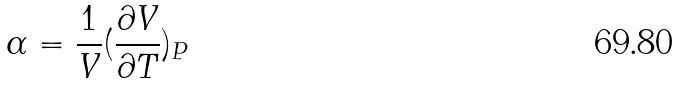Convert formula to latex. <formula><loc_0><loc_0><loc_500><loc_500>\alpha = \frac { 1 } { V } ( \frac { \partial V } { \partial T } ) _ { P }</formula> 